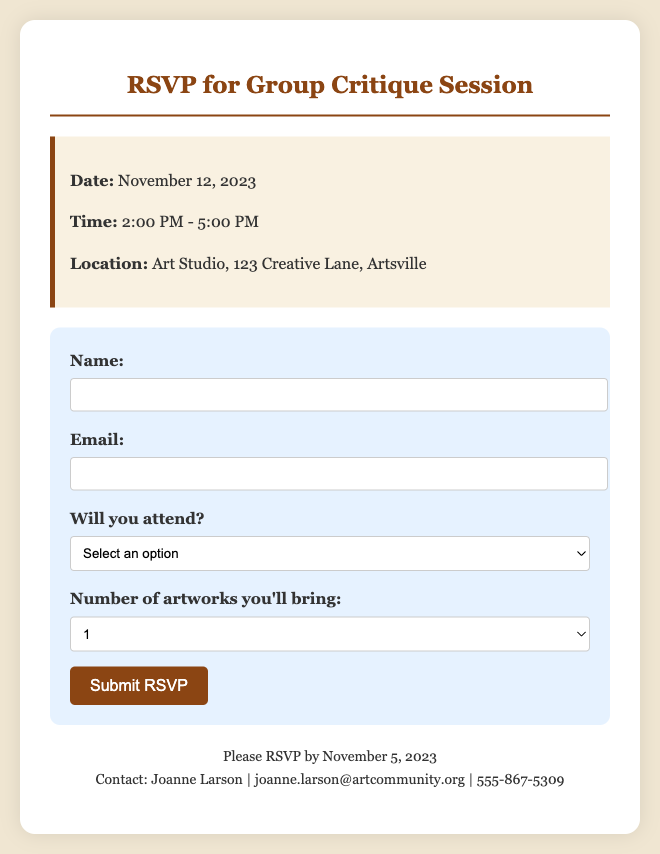what is the date of the event? The event date is clearly stated in the document under event details.
Answer: November 12, 2023 what time does the group critique session start? The start time is specified in the time section of the event details.
Answer: 2:00 PM where is the group critique session taking place? The location of the event is mentioned in the event details section.
Answer: Art Studio, 123 Creative Lane, Artsville what is the deadline to RSVP? The RSVP deadline is provided in the contact section of the document.
Answer: November 5, 2023 who should be contacted for more information? The contact person is identified at the bottom of the document.
Answer: Joanne Larson how many artworks can a participant bring? The document specifies the number of artworks options in the RSVP form.
Answer: 1, 2, or 3 what is required for submitting the RSVP form? The document indicates which fields are mandatory in the RSVP form.
Answer: Name, Email, Attendance is attendance mandatory for the critique session? The RSVP form implies the necessity of indicating attendance, which suggests the importance of participation.
Answer: Yes how can participants provide feedback during the session? The nature of the session is to provide and receive constructive feedback, as stated in the invitation.
Answer: Through group critique 